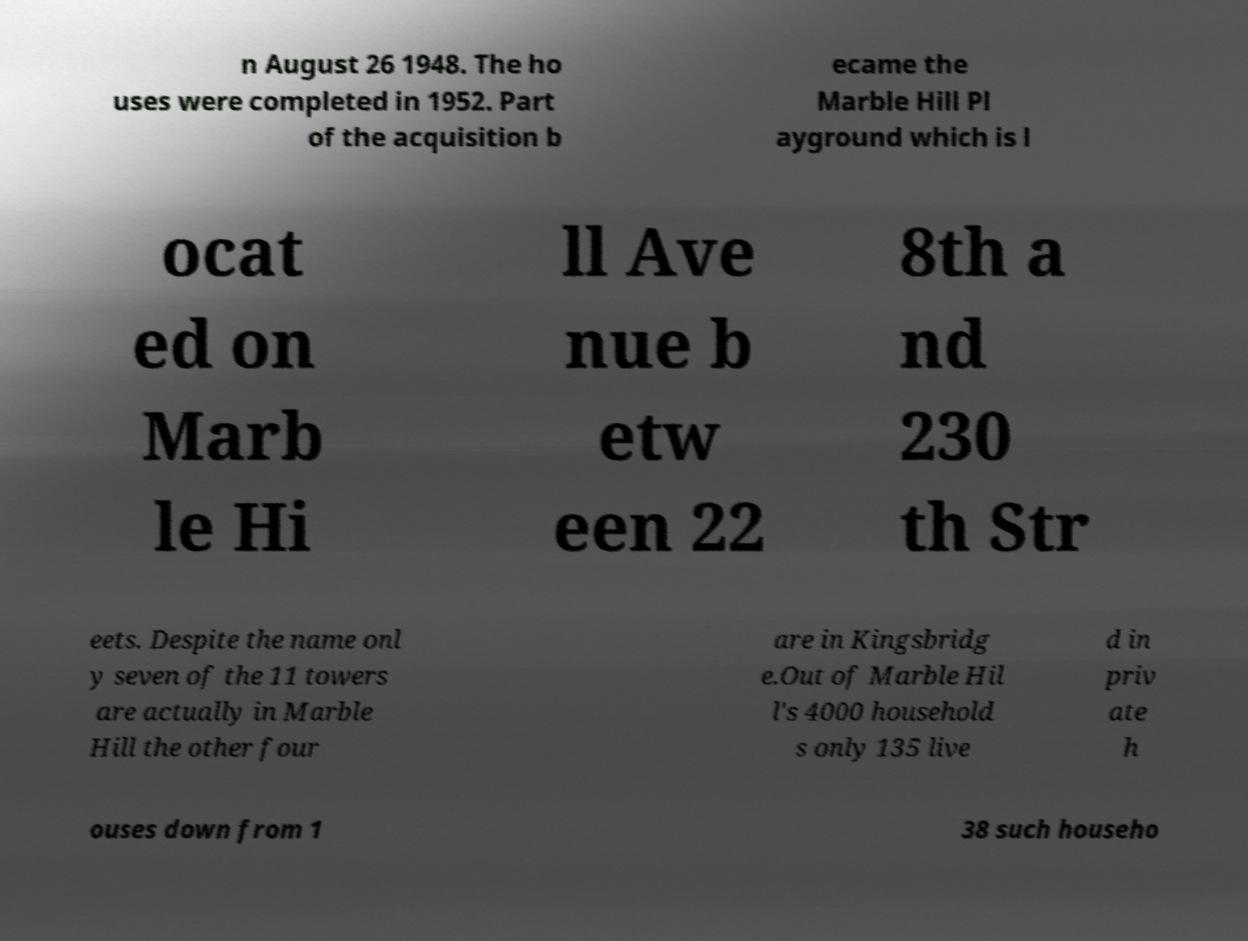Could you assist in decoding the text presented in this image and type it out clearly? n August 26 1948. The ho uses were completed in 1952. Part of the acquisition b ecame the Marble Hill Pl ayground which is l ocat ed on Marb le Hi ll Ave nue b etw een 22 8th a nd 230 th Str eets. Despite the name onl y seven of the 11 towers are actually in Marble Hill the other four are in Kingsbridg e.Out of Marble Hil l's 4000 household s only 135 live d in priv ate h ouses down from 1 38 such househo 